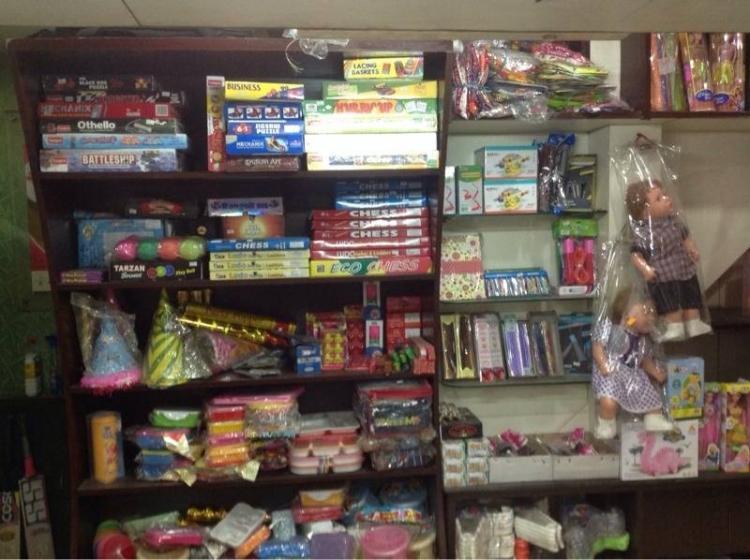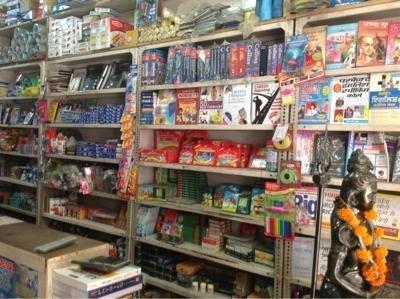The first image is the image on the left, the second image is the image on the right. For the images displayed, is the sentence "There are people and books." factually correct? Answer yes or no. No. The first image is the image on the left, the second image is the image on the right. Evaluate the accuracy of this statement regarding the images: "In at  least one image there is a single man with black hair and brown skin in a button up shirt surrounded by at least 100 books.". Is it true? Answer yes or no. No. 